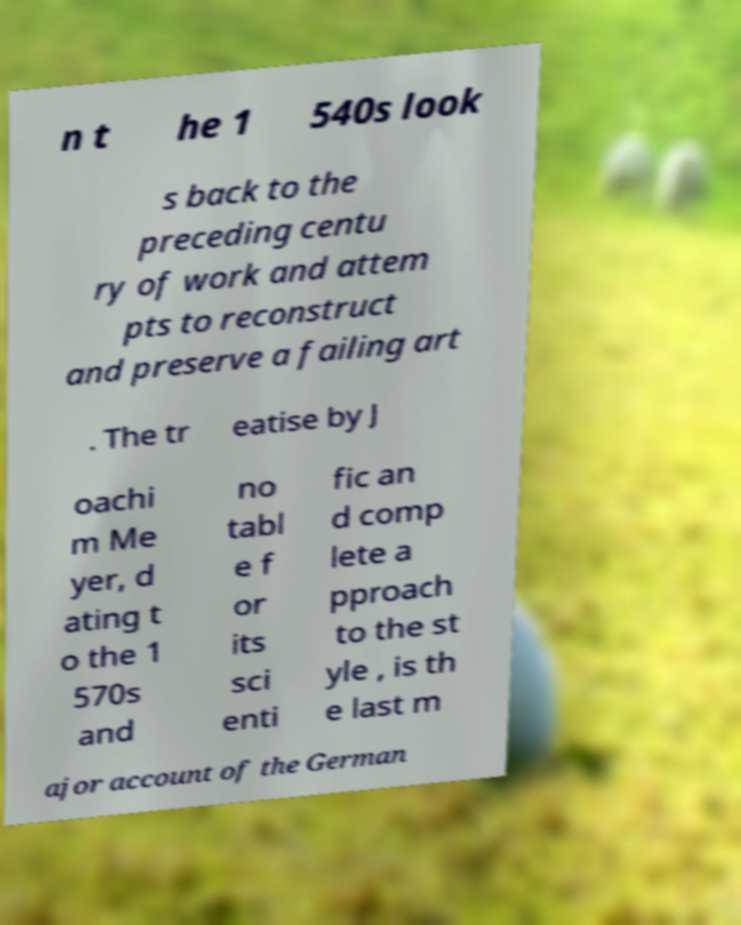What messages or text are displayed in this image? I need them in a readable, typed format. n t he 1 540s look s back to the preceding centu ry of work and attem pts to reconstruct and preserve a failing art . The tr eatise by J oachi m Me yer, d ating t o the 1 570s and no tabl e f or its sci enti fic an d comp lete a pproach to the st yle , is th e last m ajor account of the German 